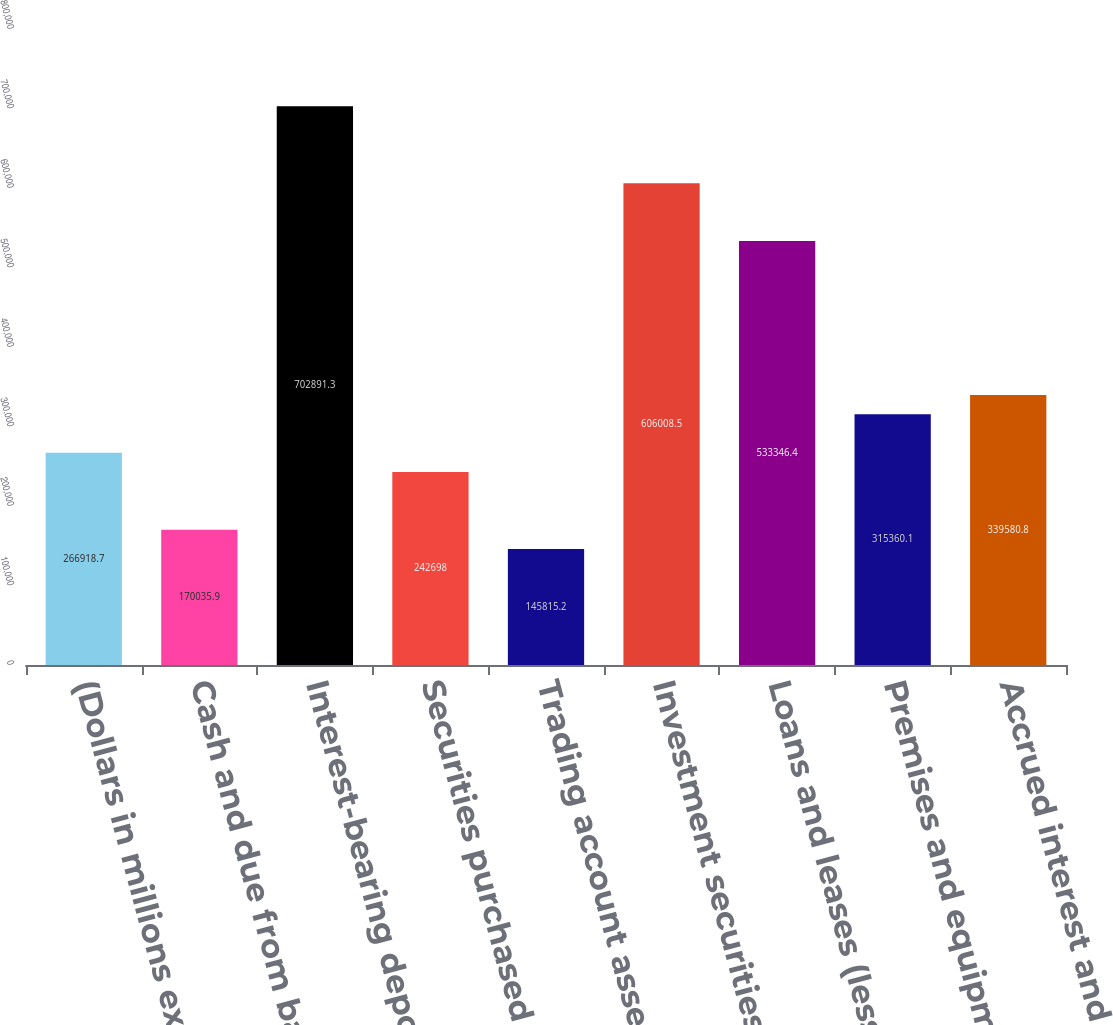Convert chart to OTSL. <chart><loc_0><loc_0><loc_500><loc_500><bar_chart><fcel>(Dollars in millions except<fcel>Cash and due from banks<fcel>Interest-bearing deposits with<fcel>Securities purchased under<fcel>Trading account assets<fcel>Investment securities<fcel>Loans and leases (less<fcel>Premises and equipment (net of<fcel>Accrued interest and fees<nl><fcel>266919<fcel>170036<fcel>702891<fcel>242698<fcel>145815<fcel>606008<fcel>533346<fcel>315360<fcel>339581<nl></chart> 